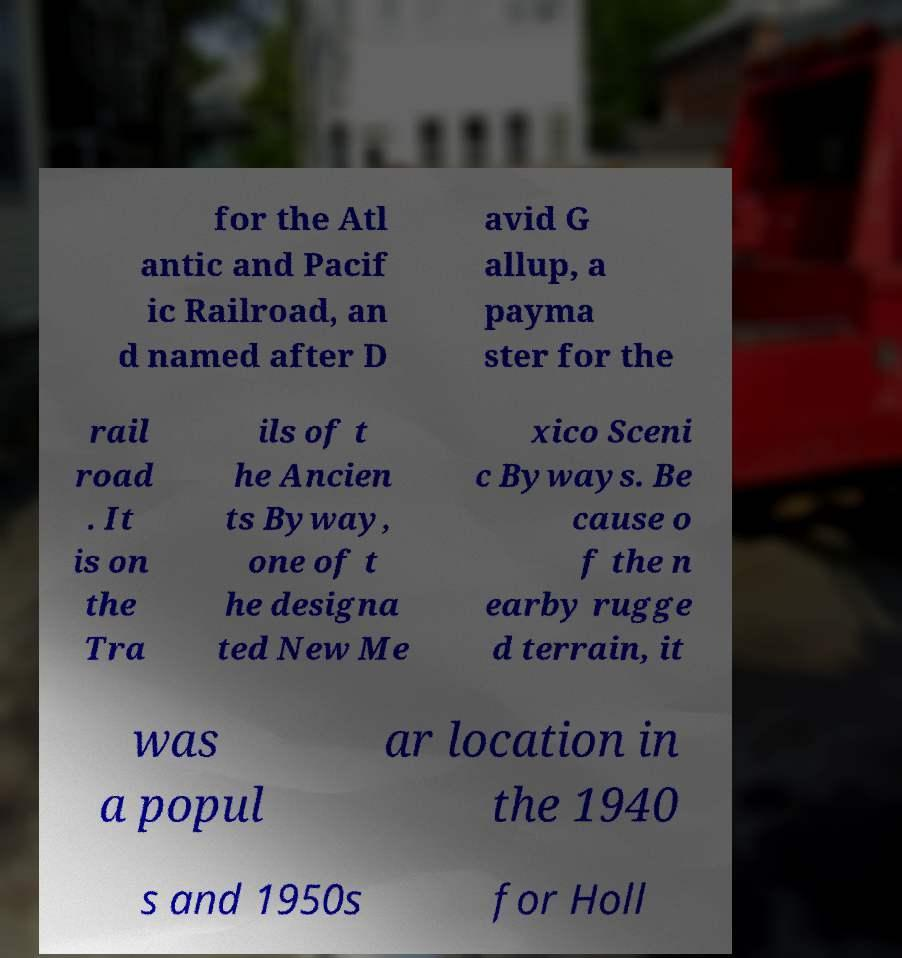Please identify and transcribe the text found in this image. for the Atl antic and Pacif ic Railroad, an d named after D avid G allup, a payma ster for the rail road . It is on the Tra ils of t he Ancien ts Byway, one of t he designa ted New Me xico Sceni c Byways. Be cause o f the n earby rugge d terrain, it was a popul ar location in the 1940 s and 1950s for Holl 